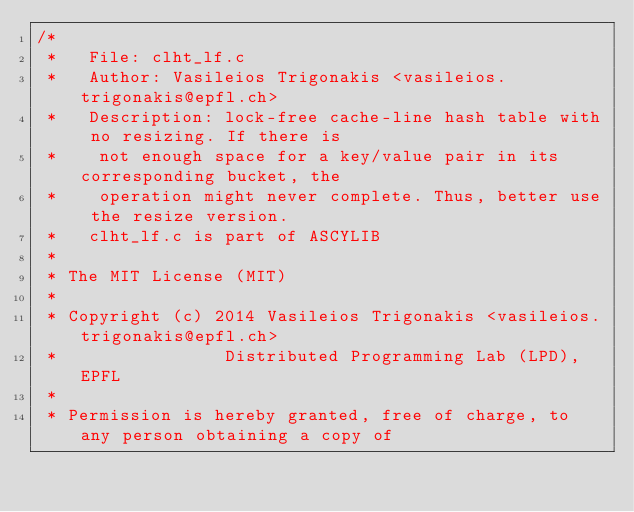<code> <loc_0><loc_0><loc_500><loc_500><_C_>/*   
 *   File: clht_lf.c
 *   Author: Vasileios Trigonakis <vasileios.trigonakis@epfl.ch>
 *   Description: lock-free cache-line hash table with no resizing. If there is
 *    not enough space for a key/value pair in its corresponding bucket, the 
 *    operation might never complete. Thus, better use the resize version.
 *   clht_lf.c is part of ASCYLIB
 *
 * The MIT License (MIT)
 *
 * Copyright (c) 2014 Vasileios Trigonakis <vasileios.trigonakis@epfl.ch>
 *	      	      Distributed Programming Lab (LPD), EPFL
 *
 * Permission is hereby granted, free of charge, to any person obtaining a copy of</code> 